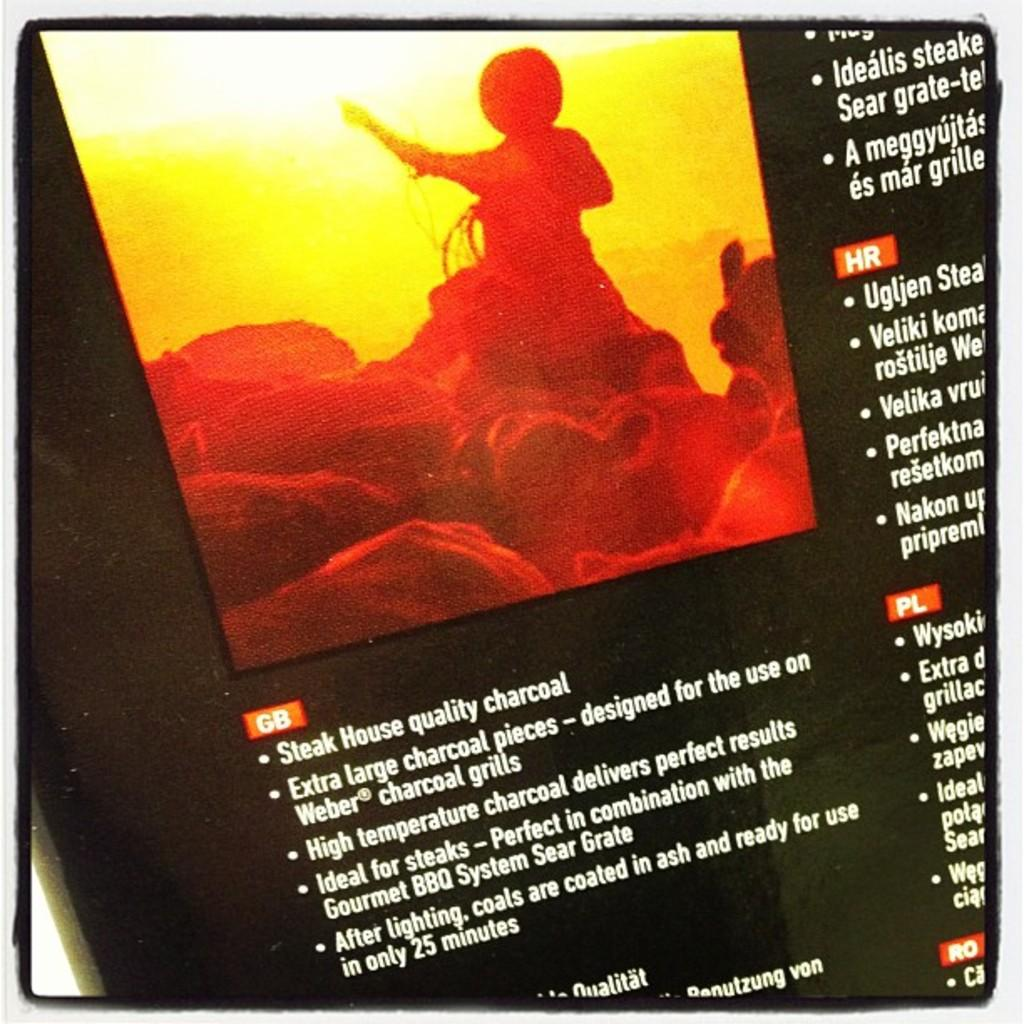<image>
Relay a brief, clear account of the picture shown. A picture of cattle with Steak House quality charcoal. 